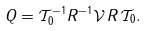Convert formula to latex. <formula><loc_0><loc_0><loc_500><loc_500>Q = \mathcal { T } ^ { - 1 } _ { 0 } R ^ { - 1 } { \mathcal { V } } \, R \, \mathcal { T } _ { 0 } .</formula> 